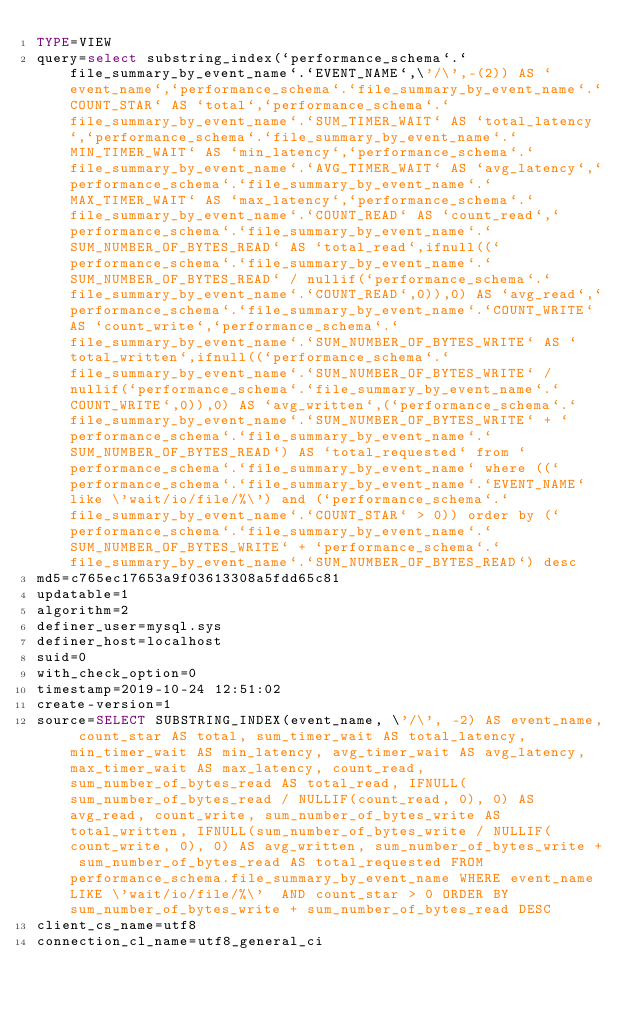Convert code to text. <code><loc_0><loc_0><loc_500><loc_500><_VisualBasic_>TYPE=VIEW
query=select substring_index(`performance_schema`.`file_summary_by_event_name`.`EVENT_NAME`,\'/\',-(2)) AS `event_name`,`performance_schema`.`file_summary_by_event_name`.`COUNT_STAR` AS `total`,`performance_schema`.`file_summary_by_event_name`.`SUM_TIMER_WAIT` AS `total_latency`,`performance_schema`.`file_summary_by_event_name`.`MIN_TIMER_WAIT` AS `min_latency`,`performance_schema`.`file_summary_by_event_name`.`AVG_TIMER_WAIT` AS `avg_latency`,`performance_schema`.`file_summary_by_event_name`.`MAX_TIMER_WAIT` AS `max_latency`,`performance_schema`.`file_summary_by_event_name`.`COUNT_READ` AS `count_read`,`performance_schema`.`file_summary_by_event_name`.`SUM_NUMBER_OF_BYTES_READ` AS `total_read`,ifnull((`performance_schema`.`file_summary_by_event_name`.`SUM_NUMBER_OF_BYTES_READ` / nullif(`performance_schema`.`file_summary_by_event_name`.`COUNT_READ`,0)),0) AS `avg_read`,`performance_schema`.`file_summary_by_event_name`.`COUNT_WRITE` AS `count_write`,`performance_schema`.`file_summary_by_event_name`.`SUM_NUMBER_OF_BYTES_WRITE` AS `total_written`,ifnull((`performance_schema`.`file_summary_by_event_name`.`SUM_NUMBER_OF_BYTES_WRITE` / nullif(`performance_schema`.`file_summary_by_event_name`.`COUNT_WRITE`,0)),0) AS `avg_written`,(`performance_schema`.`file_summary_by_event_name`.`SUM_NUMBER_OF_BYTES_WRITE` + `performance_schema`.`file_summary_by_event_name`.`SUM_NUMBER_OF_BYTES_READ`) AS `total_requested` from `performance_schema`.`file_summary_by_event_name` where ((`performance_schema`.`file_summary_by_event_name`.`EVENT_NAME` like \'wait/io/file/%\') and (`performance_schema`.`file_summary_by_event_name`.`COUNT_STAR` > 0)) order by (`performance_schema`.`file_summary_by_event_name`.`SUM_NUMBER_OF_BYTES_WRITE` + `performance_schema`.`file_summary_by_event_name`.`SUM_NUMBER_OF_BYTES_READ`) desc
md5=c765ec17653a9f03613308a5fdd65c81
updatable=1
algorithm=2
definer_user=mysql.sys
definer_host=localhost
suid=0
with_check_option=0
timestamp=2019-10-24 12:51:02
create-version=1
source=SELECT SUBSTRING_INDEX(event_name, \'/\', -2) AS event_name, count_star AS total, sum_timer_wait AS total_latency, min_timer_wait AS min_latency, avg_timer_wait AS avg_latency, max_timer_wait AS max_latency, count_read, sum_number_of_bytes_read AS total_read, IFNULL(sum_number_of_bytes_read / NULLIF(count_read, 0), 0) AS avg_read, count_write, sum_number_of_bytes_write AS total_written, IFNULL(sum_number_of_bytes_write / NULLIF(count_write, 0), 0) AS avg_written, sum_number_of_bytes_write + sum_number_of_bytes_read AS total_requested FROM performance_schema.file_summary_by_event_name WHERE event_name LIKE \'wait/io/file/%\'  AND count_star > 0 ORDER BY sum_number_of_bytes_write + sum_number_of_bytes_read DESC
client_cs_name=utf8
connection_cl_name=utf8_general_ci</code> 